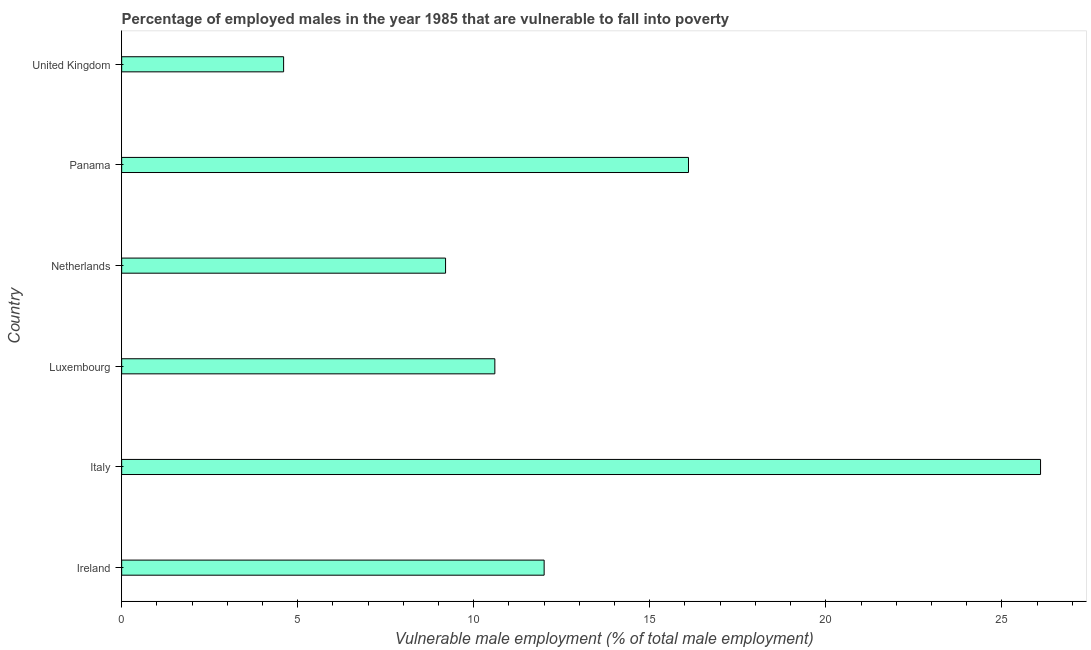What is the title of the graph?
Provide a succinct answer. Percentage of employed males in the year 1985 that are vulnerable to fall into poverty. What is the label or title of the X-axis?
Give a very brief answer. Vulnerable male employment (% of total male employment). What is the percentage of employed males who are vulnerable to fall into poverty in Netherlands?
Offer a terse response. 9.2. Across all countries, what is the maximum percentage of employed males who are vulnerable to fall into poverty?
Give a very brief answer. 26.1. Across all countries, what is the minimum percentage of employed males who are vulnerable to fall into poverty?
Your answer should be compact. 4.6. In which country was the percentage of employed males who are vulnerable to fall into poverty maximum?
Keep it short and to the point. Italy. What is the sum of the percentage of employed males who are vulnerable to fall into poverty?
Offer a terse response. 78.6. What is the median percentage of employed males who are vulnerable to fall into poverty?
Provide a succinct answer. 11.3. What is the ratio of the percentage of employed males who are vulnerable to fall into poverty in Ireland to that in United Kingdom?
Your response must be concise. 2.61. What is the difference between the highest and the second highest percentage of employed males who are vulnerable to fall into poverty?
Your answer should be compact. 10. Is the sum of the percentage of employed males who are vulnerable to fall into poverty in Ireland and Luxembourg greater than the maximum percentage of employed males who are vulnerable to fall into poverty across all countries?
Provide a succinct answer. No. What is the difference between the highest and the lowest percentage of employed males who are vulnerable to fall into poverty?
Offer a very short reply. 21.5. What is the Vulnerable male employment (% of total male employment) of Italy?
Make the answer very short. 26.1. What is the Vulnerable male employment (% of total male employment) of Luxembourg?
Ensure brevity in your answer.  10.6. What is the Vulnerable male employment (% of total male employment) of Netherlands?
Offer a terse response. 9.2. What is the Vulnerable male employment (% of total male employment) of Panama?
Your answer should be very brief. 16.1. What is the Vulnerable male employment (% of total male employment) of United Kingdom?
Provide a short and direct response. 4.6. What is the difference between the Vulnerable male employment (% of total male employment) in Ireland and Italy?
Provide a short and direct response. -14.1. What is the difference between the Vulnerable male employment (% of total male employment) in Ireland and Luxembourg?
Your answer should be very brief. 1.4. What is the difference between the Vulnerable male employment (% of total male employment) in Ireland and United Kingdom?
Make the answer very short. 7.4. What is the difference between the Vulnerable male employment (% of total male employment) in Italy and Luxembourg?
Your response must be concise. 15.5. What is the difference between the Vulnerable male employment (% of total male employment) in Luxembourg and Panama?
Give a very brief answer. -5.5. What is the difference between the Vulnerable male employment (% of total male employment) in Luxembourg and United Kingdom?
Keep it short and to the point. 6. What is the ratio of the Vulnerable male employment (% of total male employment) in Ireland to that in Italy?
Your response must be concise. 0.46. What is the ratio of the Vulnerable male employment (% of total male employment) in Ireland to that in Luxembourg?
Your response must be concise. 1.13. What is the ratio of the Vulnerable male employment (% of total male employment) in Ireland to that in Netherlands?
Provide a short and direct response. 1.3. What is the ratio of the Vulnerable male employment (% of total male employment) in Ireland to that in Panama?
Ensure brevity in your answer.  0.74. What is the ratio of the Vulnerable male employment (% of total male employment) in Ireland to that in United Kingdom?
Your response must be concise. 2.61. What is the ratio of the Vulnerable male employment (% of total male employment) in Italy to that in Luxembourg?
Ensure brevity in your answer.  2.46. What is the ratio of the Vulnerable male employment (% of total male employment) in Italy to that in Netherlands?
Offer a terse response. 2.84. What is the ratio of the Vulnerable male employment (% of total male employment) in Italy to that in Panama?
Offer a very short reply. 1.62. What is the ratio of the Vulnerable male employment (% of total male employment) in Italy to that in United Kingdom?
Your response must be concise. 5.67. What is the ratio of the Vulnerable male employment (% of total male employment) in Luxembourg to that in Netherlands?
Provide a short and direct response. 1.15. What is the ratio of the Vulnerable male employment (% of total male employment) in Luxembourg to that in Panama?
Offer a very short reply. 0.66. What is the ratio of the Vulnerable male employment (% of total male employment) in Luxembourg to that in United Kingdom?
Ensure brevity in your answer.  2.3. What is the ratio of the Vulnerable male employment (% of total male employment) in Netherlands to that in Panama?
Your answer should be compact. 0.57. What is the ratio of the Vulnerable male employment (% of total male employment) in Netherlands to that in United Kingdom?
Offer a very short reply. 2. What is the ratio of the Vulnerable male employment (% of total male employment) in Panama to that in United Kingdom?
Your response must be concise. 3.5. 